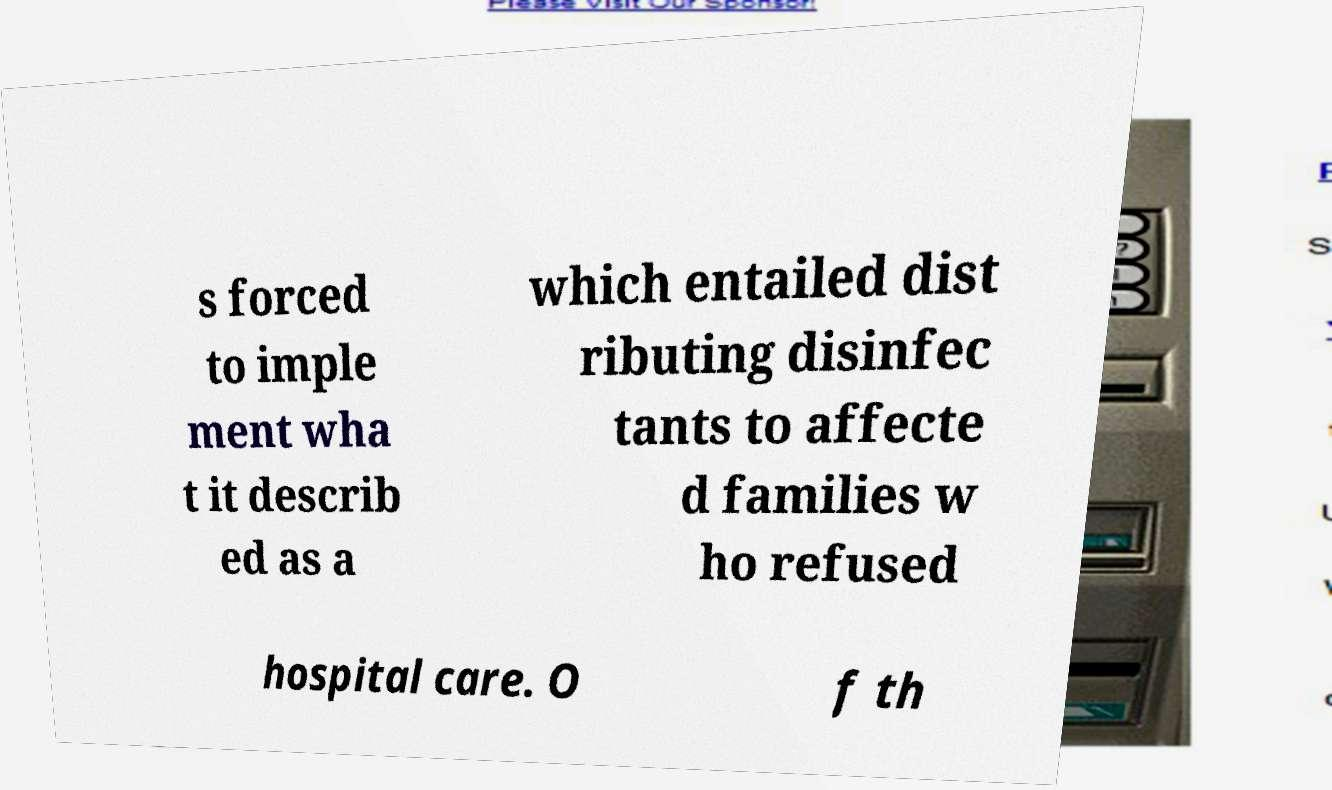Please identify and transcribe the text found in this image. s forced to imple ment wha t it describ ed as a which entailed dist ributing disinfec tants to affecte d families w ho refused hospital care. O f th 